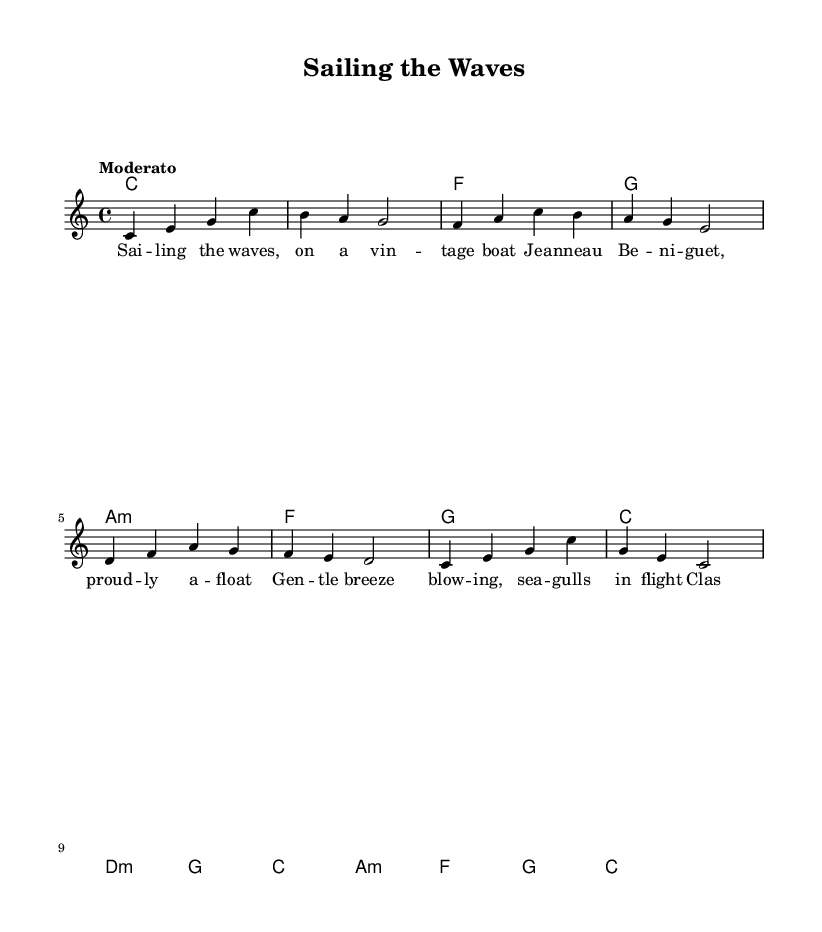What is the key signature of this music? The key signature is C major, which has no sharps or flats.
Answer: C major What is the time signature of this piece? The time signature of the piece is indicated as 4/4, meaning four beats per measure.
Answer: 4/4 What is the tempo marking for this composition? The tempo marking shows "Moderato," indicating a moderate pace for the piece.
Answer: Moderato How many measures are in the melody? By counting the distinct melodic sections indicated in the sheet music, we can determine that there are 8 measures in total.
Answer: 8 What chord follows the D minor chord in the progression? The chord progression shows that G major follows the D minor chord.
Answer: G What is the overall theme highlighted in the lyrics? The lyrics reflect a journey of sailing on a vintage boat and enjoying classic sailing songs under the gentle breeze.
Answer: Sailing 